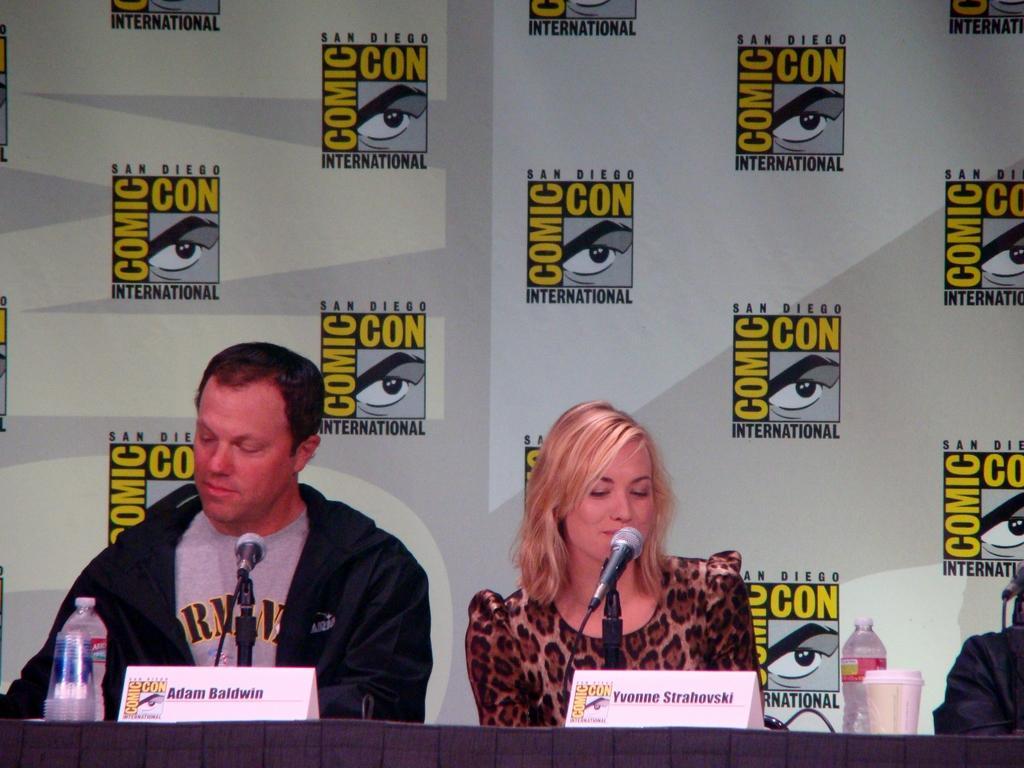How would you summarize this image in a sentence or two? In this picture we can see there are three people sitting on chairs and in front of the people there is a table and on the table there are name boards, bottles, cup, disposable glasses and the microphones with stands and cables and behind the people there is a board. 